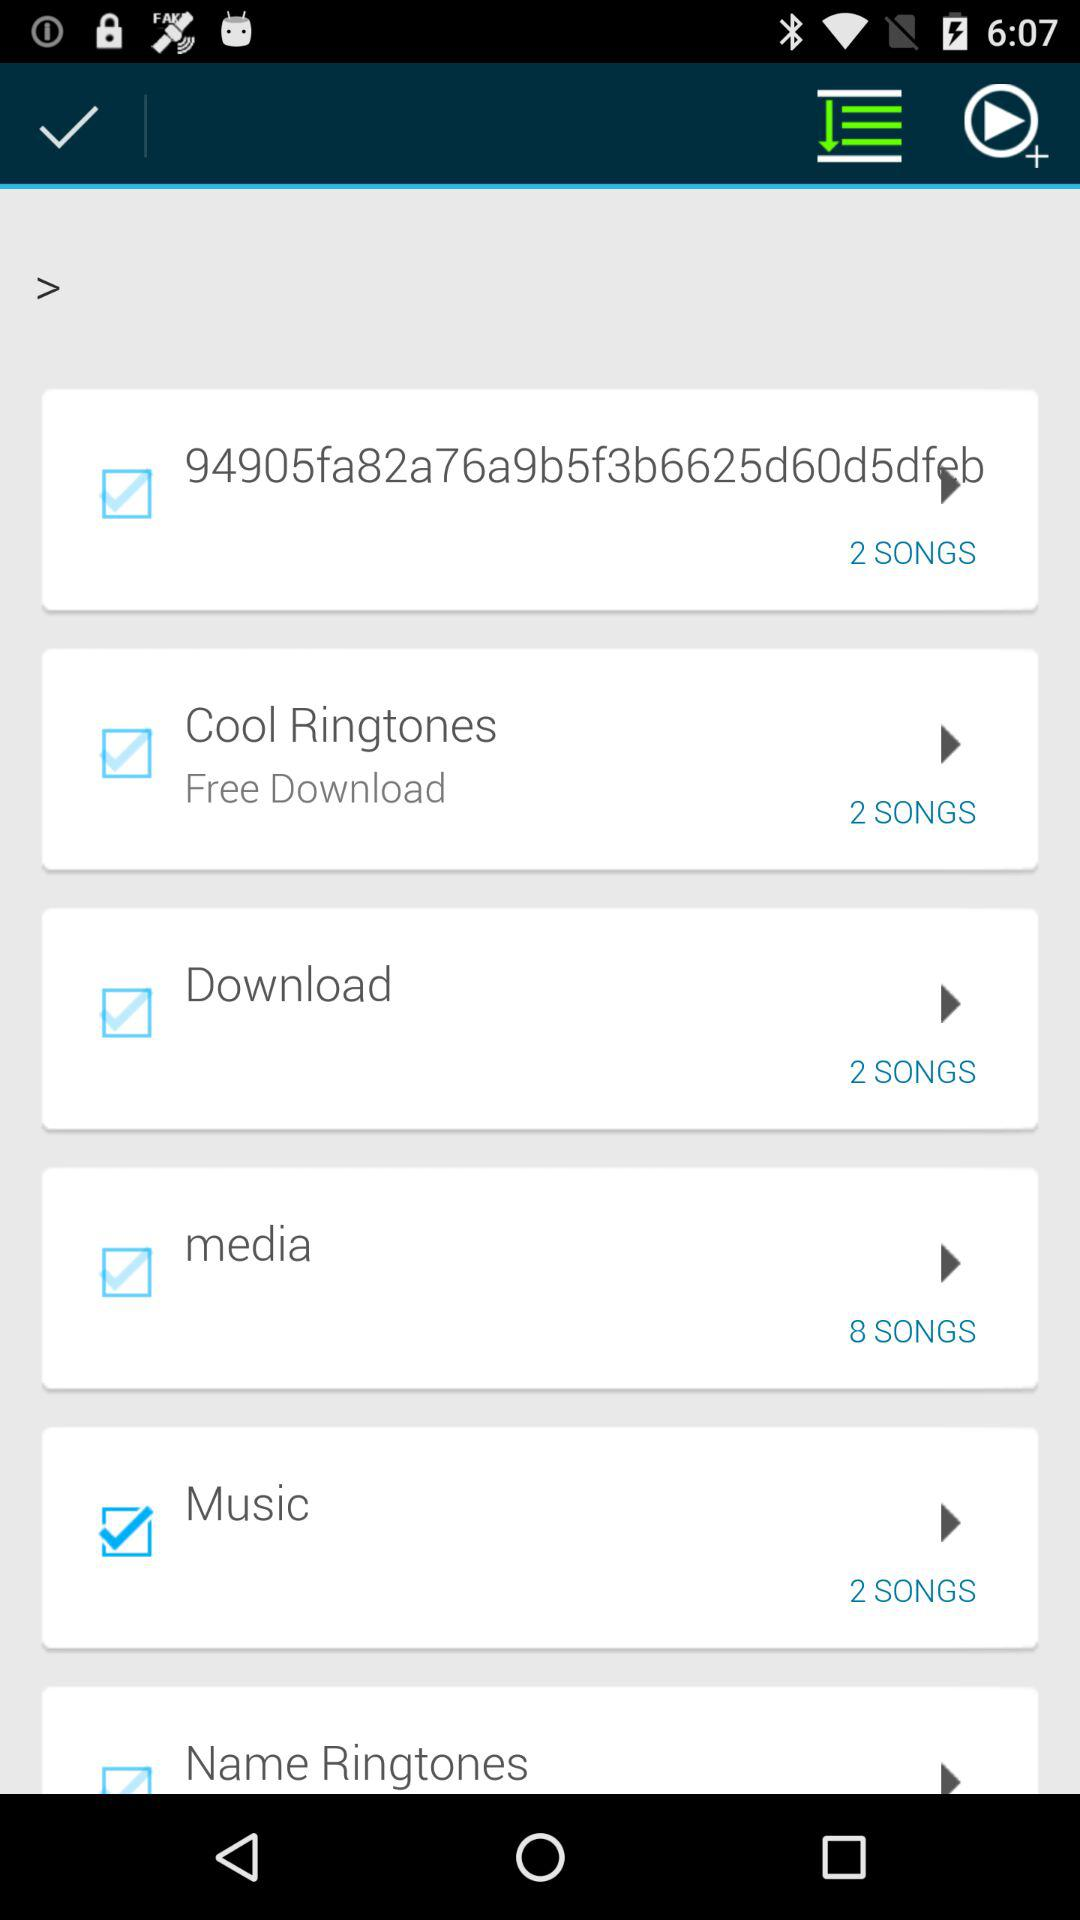How many downloaded songs are there? There are 2 downloaded songs. 